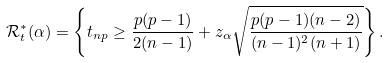Convert formula to latex. <formula><loc_0><loc_0><loc_500><loc_500>\mathcal { R } _ { t } ^ { * } ( \alpha ) = \left \{ t _ { n p } \geq \frac { p ( p - 1 ) } { 2 ( n - 1 ) } + z _ { \alpha } \sqrt { \frac { p ( p - 1 ) ( n - 2 ) } { ( n - 1 ) ^ { 2 } ( n + 1 ) } } \right \} .</formula> 